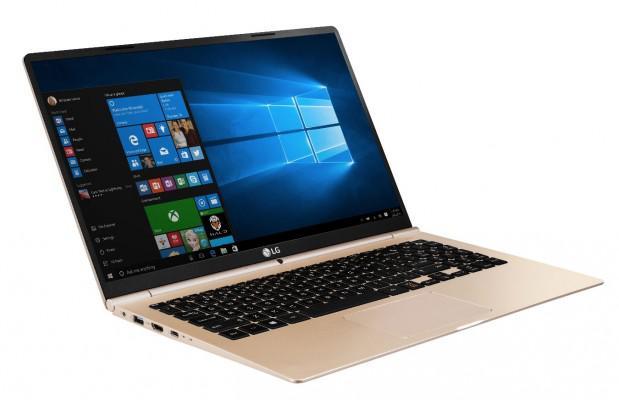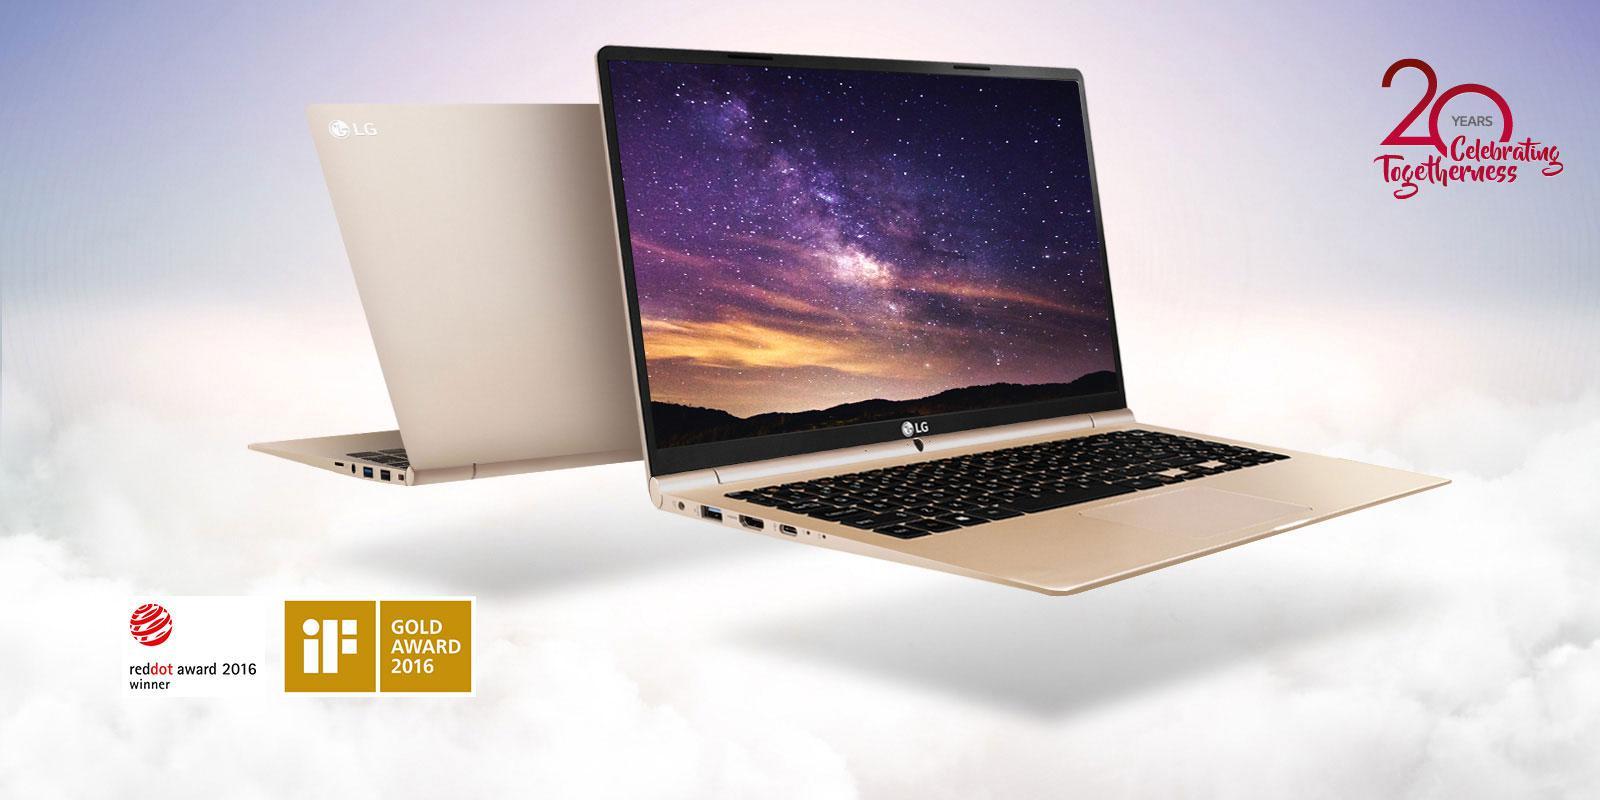The first image is the image on the left, the second image is the image on the right. For the images displayed, is the sentence "At least one of the laptops has a blank screen." factually correct? Answer yes or no. No. The first image is the image on the left, the second image is the image on the right. Examine the images to the left and right. Is the description "Each image contains exactly one open laptop, at least one image contains a laptop with something displayed on its screen, and the laptops on the left and right face different directions." accurate? Answer yes or no. No. 